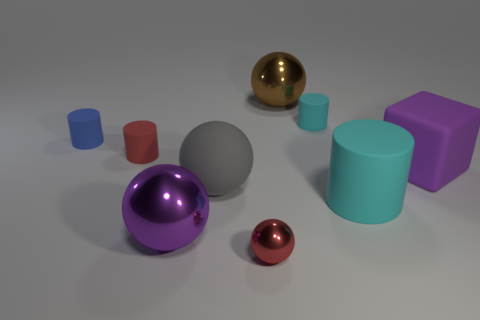Are any gray cubes visible? no 